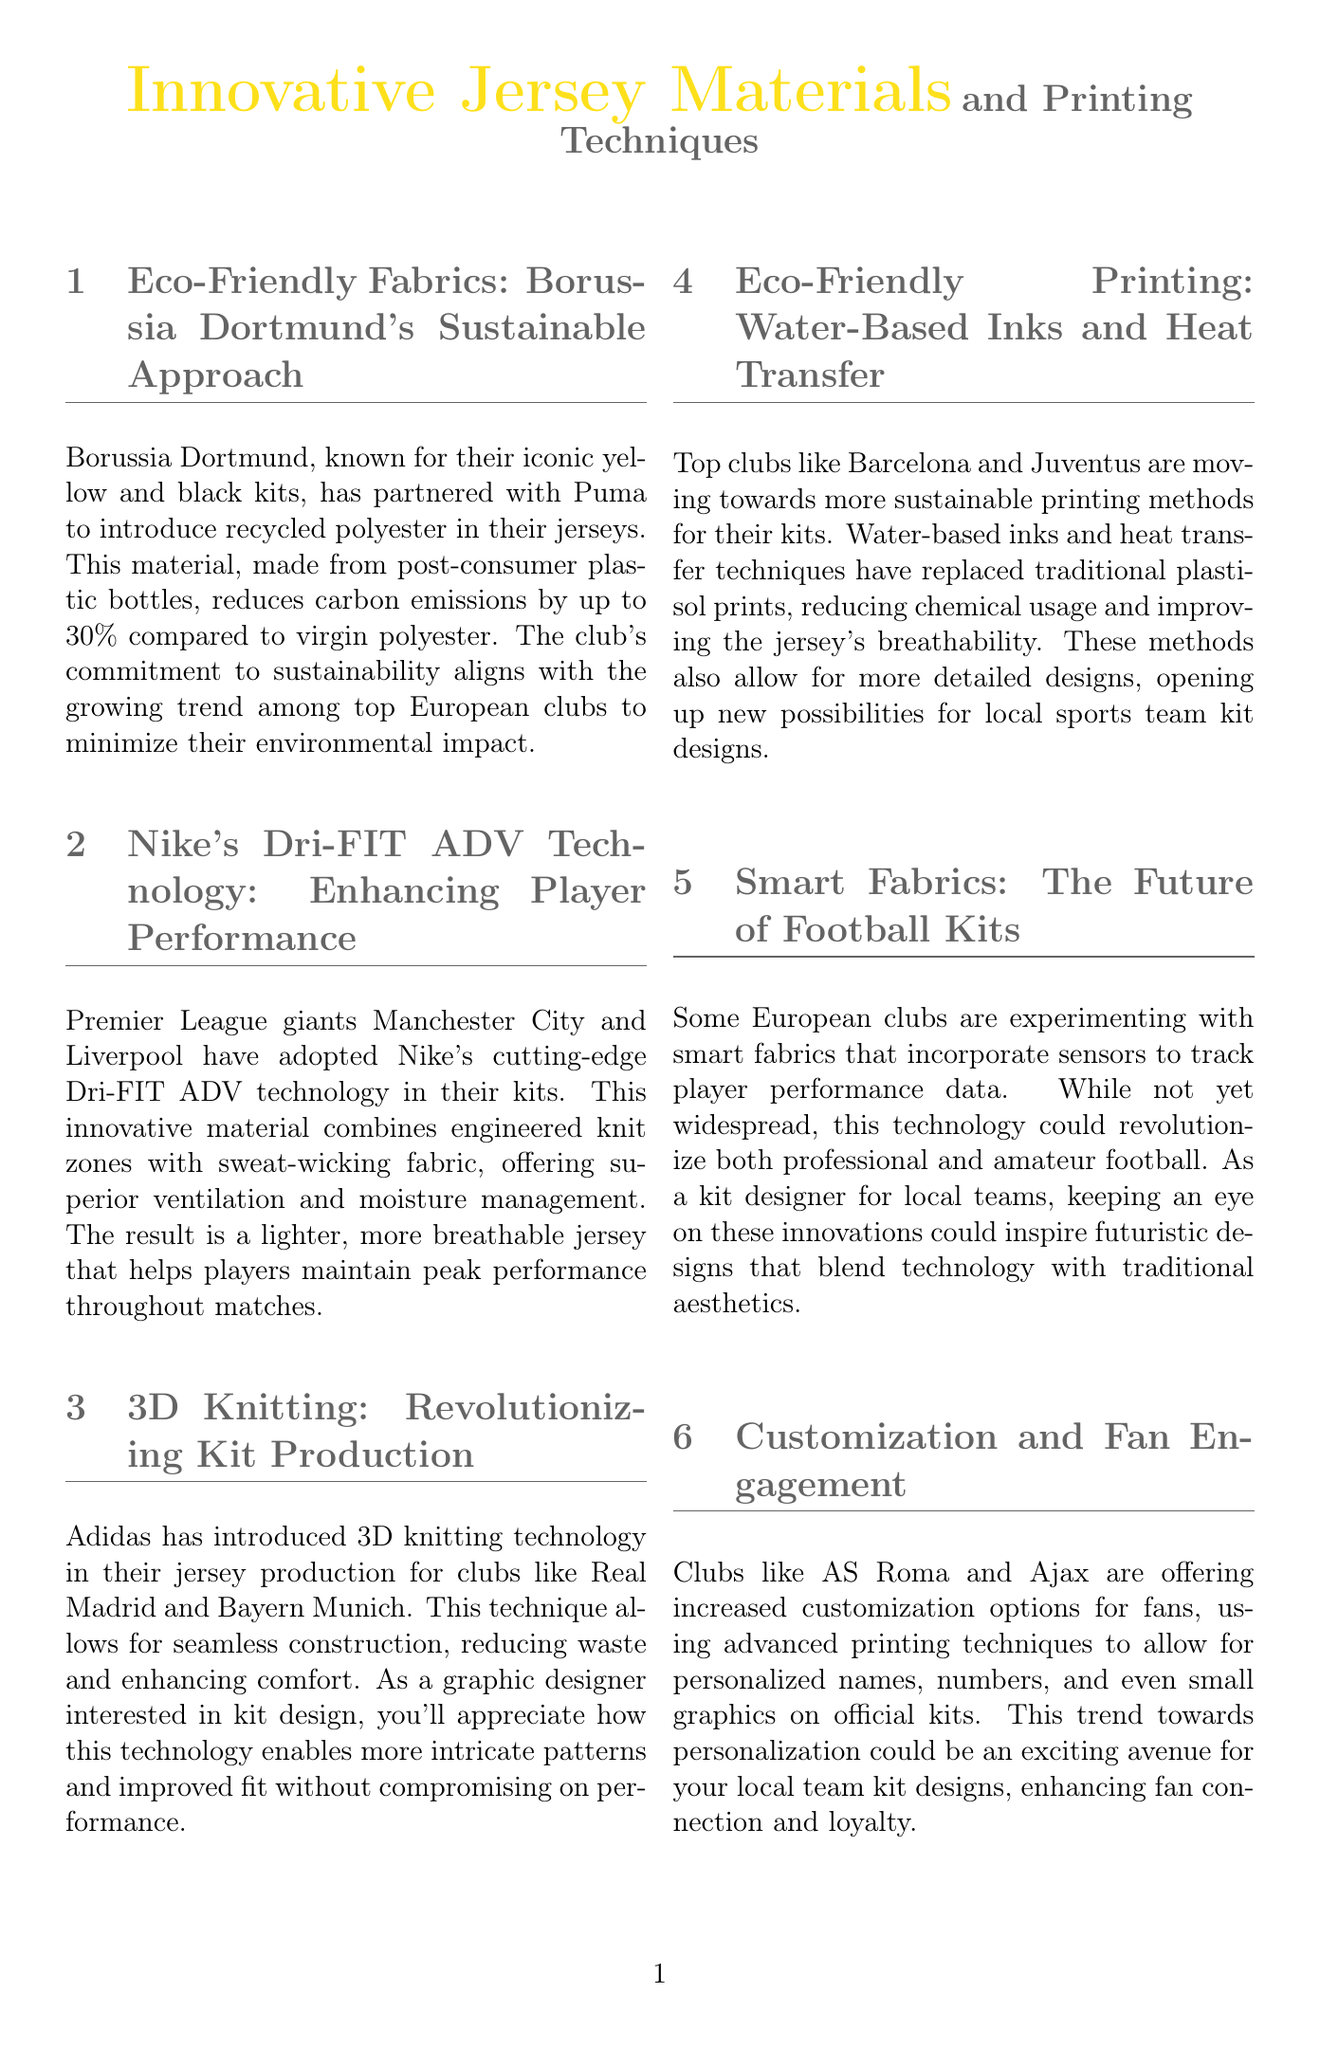What sustainable material does Borussia Dortmund use in their jerseys? The newsletter states that Borussia Dortmund has introduced recycled polyester, made from post-consumer plastic bottles, in their jerseys.
Answer: recycled polyester What technology do Manchester City and Liverpool use to enhance player performance? The document mentions that Manchester City and Liverpool have adopted Nike's Dri-FIT ADV technology in their kits for improved performance.
Answer: Dri-FIT ADV technology Which clubs are mentioned as using 3D knitting technology in their jersey production? The newsletter specifies that Adidas has introduced 3D knitting technology for clubs like Real Madrid and Bayern Munich.
Answer: Real Madrid and Bayern Munich What is a benefit of water-based inks and heat transfer printing methods? The document states that these methods reduce chemical usage and improve the jersey's breathability.
Answer: reduce chemical usage and improve breathability What is a possible future innovation in football kits mentioned in the newsletter? The newsletter discusses the experimentation with smart fabrics that incorporate sensors to track player performance data as a future innovation.
Answer: smart fabrics Which clubs are offering increased customization options for fans? The document identifies AS Roma and Ajax as clubs providing more customization options on their kits.
Answer: AS Roma and Ajax What is the primary goal behind Borussia Dortmund's sustainability initiatives? The news highlights that Borussia Dortmund's sustainability efforts align with the trend among top European clubs to minimize their environmental impact.
Answer: minimize environmental impact What technique allows for seamless construction in jersey production? The newsletter mentions that the 3D knitting technology introduced by Adidas allows for seamless construction.
Answer: 3D knitting technology 